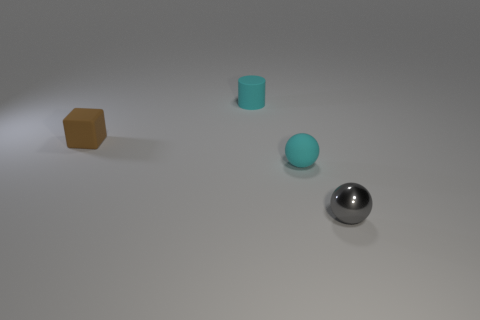Is there anything else that is the same material as the gray object?
Offer a terse response. No. Do the matte sphere and the tiny cylinder to the right of the brown thing have the same color?
Your response must be concise. Yes. What number of other objects are there of the same color as the rubber cylinder?
Your answer should be compact. 1. Are there fewer tiny brown rubber objects than big green metallic balls?
Keep it short and to the point. No. What color is the tiny thing that is both in front of the tiny rubber cylinder and behind the tiny cyan ball?
Ensure brevity in your answer.  Brown. There is a tiny cyan thing that is the same shape as the tiny gray shiny thing; what is it made of?
Your response must be concise. Rubber. Is there anything else that has the same size as the gray shiny thing?
Make the answer very short. Yes. Is the number of gray blocks greater than the number of rubber balls?
Ensure brevity in your answer.  No. What size is the object that is both in front of the tiny brown thing and to the left of the tiny gray ball?
Your answer should be very brief. Small. There is a small shiny thing; what shape is it?
Your answer should be very brief. Sphere. 